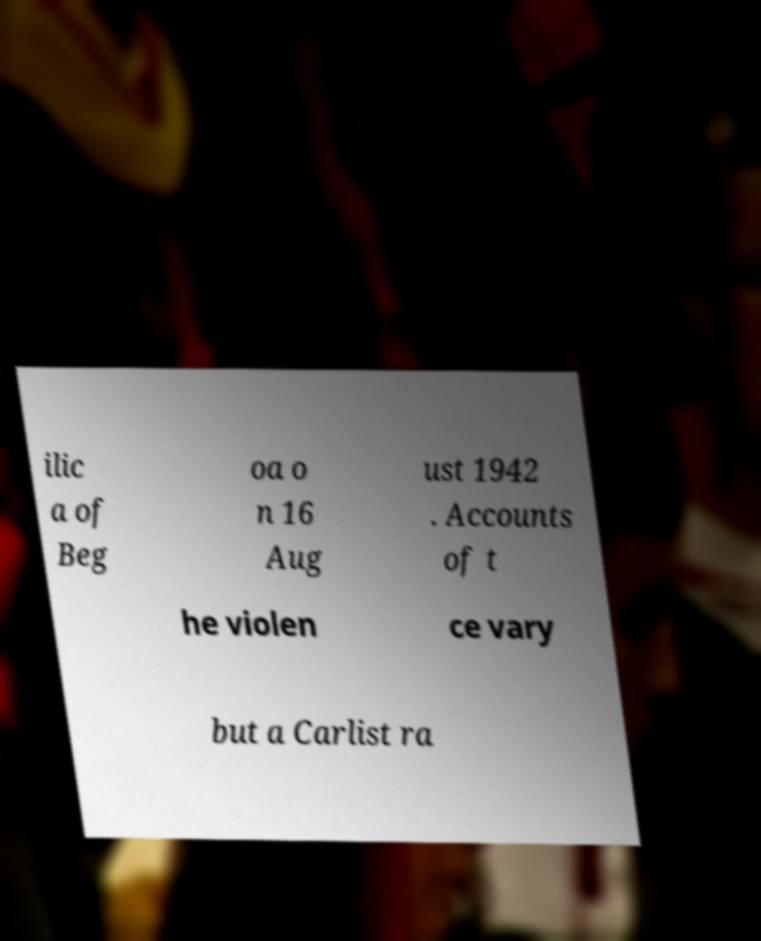I need the written content from this picture converted into text. Can you do that? ilic a of Beg oa o n 16 Aug ust 1942 . Accounts of t he violen ce vary but a Carlist ra 